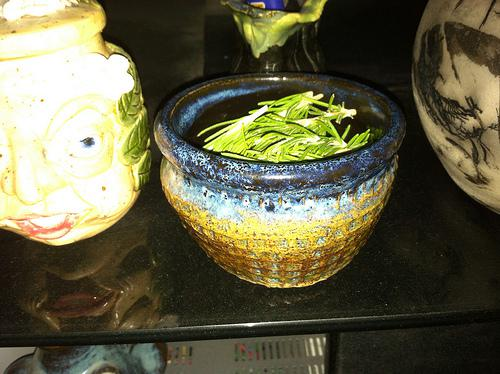Question: how many bowls are there?
Choices:
A. 1.
B. 2.
C. 4.
D. 5.
Answer with the letter. Answer: A Question: what is on the vase on the left?
Choices:
A. Apples.
B. Flowers.
C. Face.
D. Bananas.
Answer with the letter. Answer: C Question: what color are the leaves in the bowl?
Choices:
A. Brown.
B. Orange.
C. Red.
D. Green.
Answer with the letter. Answer: D Question: what is the bowl sitting on?
Choices:
A. Table.
B. Desk.
C. Dresser.
D. Counter.
Answer with the letter. Answer: A Question: what color are the lips on the vase?
Choices:
A. Purple.
B. Black.
C. Red.
D. Gold.
Answer with the letter. Answer: C 